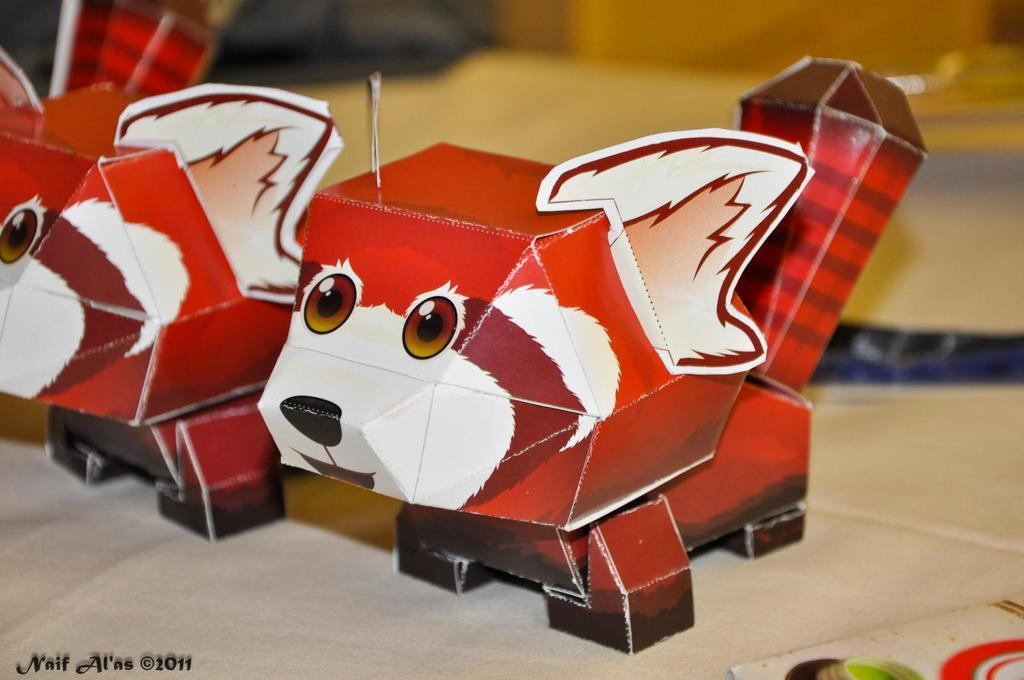What type of objects are featured in the image? There are paper crafts in the image. Where are the paper crafts located? The paper crafts are on a platform. Can you describe the background of the image? The background of the image is blurred. Reasoning: Let' Let's think step by step in order to produce the conversation. We start by identifying the main subject in the image, which is the paper crafts. Then, we expand the conversation to include the location of the paper crafts and the appearance of the background. Each question is designed to elicit a specific detail about the image that is known from the provided facts. Absurd Question/Answer: What type of bottle is visible in the image? There is no bottle present in the image; it features paper crafts on a platform with a blurred background. Is there a camera visible in the image? There is no camera present in the image; it features paper crafts on a platform with a blurred background. --- Facts: 1. There is a person sitting on a chair in the image. 2. The person is holding a book. 3. The book has a blue cover. 4. The chair is made of wood. 5. There is a table next to the chair. Absurd Topics: elephant, ocean, bicycle Conversation: What is the person in the image doing? The person is sitting on a chair in the image. What is the person holding in the image? The person is holding a book in the image. What color is the book's cover? The book has a blue cover. What is the chair made of? The chair is made of wood. What is located next to the chair? There is a table next to the chair. Reasoning: Let's think step by step in order to produce the conversation. We start by identifying the main subject in the image, which is the person sitting on a chair. Then, we expand the conversation to include the object the person is holding (a book), the color of the book's cover, the material of the chair, and the presence of a table next 